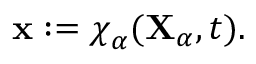<formula> <loc_0><loc_0><loc_500><loc_500>\begin{array} { r } { x \colon = \chi _ { \alpha } ( X _ { \alpha } , t ) . } \end{array}</formula> 